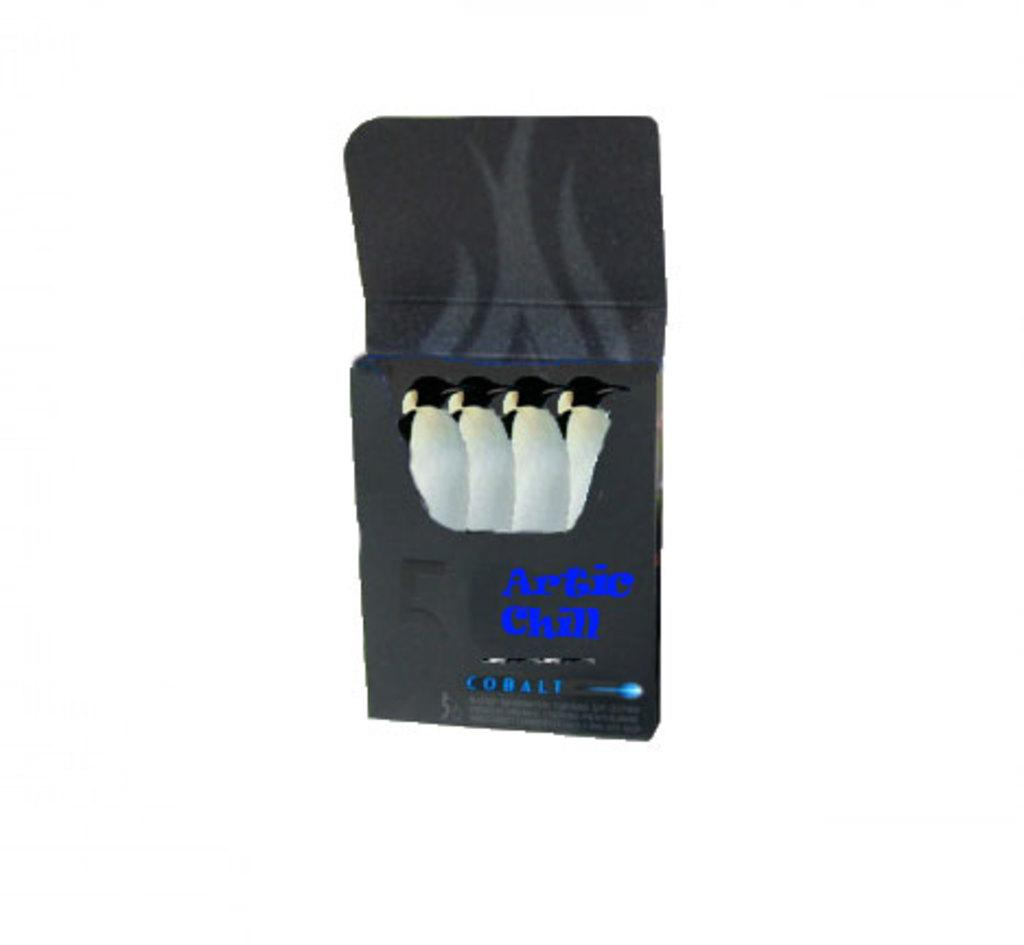<image>
Render a clear and concise summary of the photo. A pack of Artic Chill gum is the flavor Cobalt. 